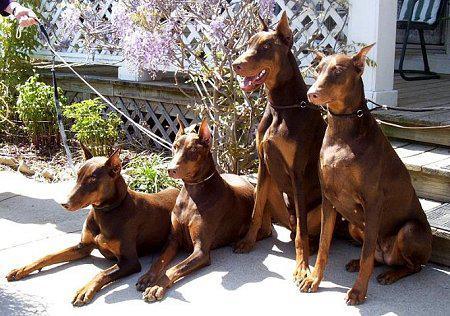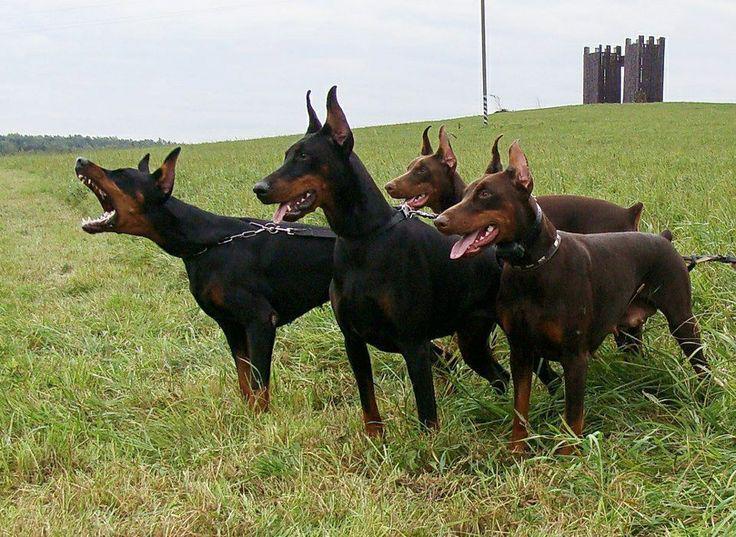The first image is the image on the left, the second image is the image on the right. Assess this claim about the two images: "The right image contains exactly five dogs.". Correct or not? Answer yes or no. No. The first image is the image on the left, the second image is the image on the right. Considering the images on both sides, is "All dogs are pointy-eared adult dobermans, and at least seven dogs in total are shown." valid? Answer yes or no. Yes. 